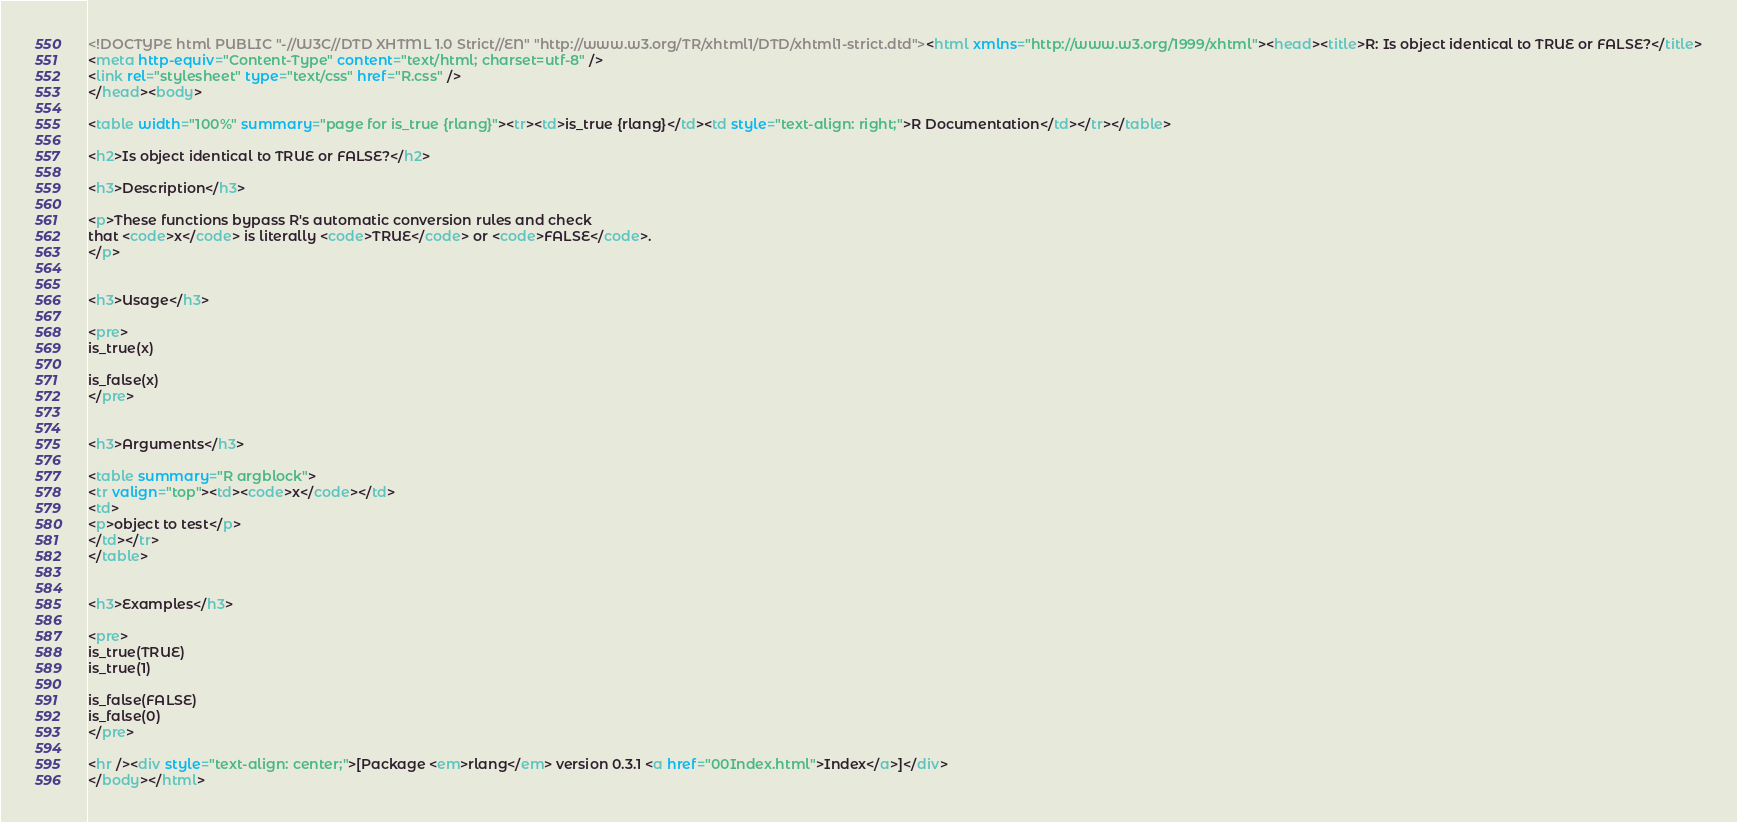<code> <loc_0><loc_0><loc_500><loc_500><_HTML_><!DOCTYPE html PUBLIC "-//W3C//DTD XHTML 1.0 Strict//EN" "http://www.w3.org/TR/xhtml1/DTD/xhtml1-strict.dtd"><html xmlns="http://www.w3.org/1999/xhtml"><head><title>R: Is object identical to TRUE or FALSE?</title>
<meta http-equiv="Content-Type" content="text/html; charset=utf-8" />
<link rel="stylesheet" type="text/css" href="R.css" />
</head><body>

<table width="100%" summary="page for is_true {rlang}"><tr><td>is_true {rlang}</td><td style="text-align: right;">R Documentation</td></tr></table>

<h2>Is object identical to TRUE or FALSE?</h2>

<h3>Description</h3>

<p>These functions bypass R's automatic conversion rules and check
that <code>x</code> is literally <code>TRUE</code> or <code>FALSE</code>.
</p>


<h3>Usage</h3>

<pre>
is_true(x)

is_false(x)
</pre>


<h3>Arguments</h3>

<table summary="R argblock">
<tr valign="top"><td><code>x</code></td>
<td>
<p>object to test</p>
</td></tr>
</table>


<h3>Examples</h3>

<pre>
is_true(TRUE)
is_true(1)

is_false(FALSE)
is_false(0)
</pre>

<hr /><div style="text-align: center;">[Package <em>rlang</em> version 0.3.1 <a href="00Index.html">Index</a>]</div>
</body></html>
</code> 